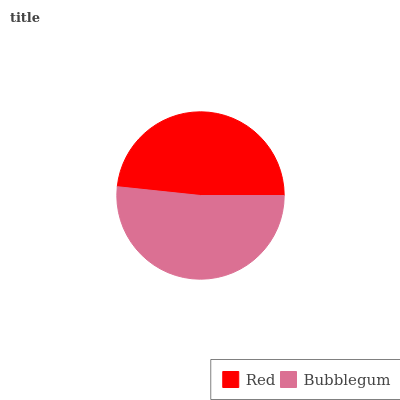Is Red the minimum?
Answer yes or no. Yes. Is Bubblegum the maximum?
Answer yes or no. Yes. Is Bubblegum the minimum?
Answer yes or no. No. Is Bubblegum greater than Red?
Answer yes or no. Yes. Is Red less than Bubblegum?
Answer yes or no. Yes. Is Red greater than Bubblegum?
Answer yes or no. No. Is Bubblegum less than Red?
Answer yes or no. No. Is Bubblegum the high median?
Answer yes or no. Yes. Is Red the low median?
Answer yes or no. Yes. Is Red the high median?
Answer yes or no. No. Is Bubblegum the low median?
Answer yes or no. No. 